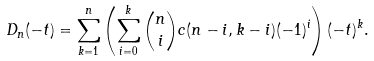Convert formula to latex. <formula><loc_0><loc_0><loc_500><loc_500>D _ { n } ( - t ) = \sum _ { k = 1 } ^ { n } \left ( \sum _ { i = 0 } ^ { k } { n \choose i } c ( n - i , k - i ) ( - 1 ) ^ { i } \right ) ( - t ) ^ { k } .</formula> 